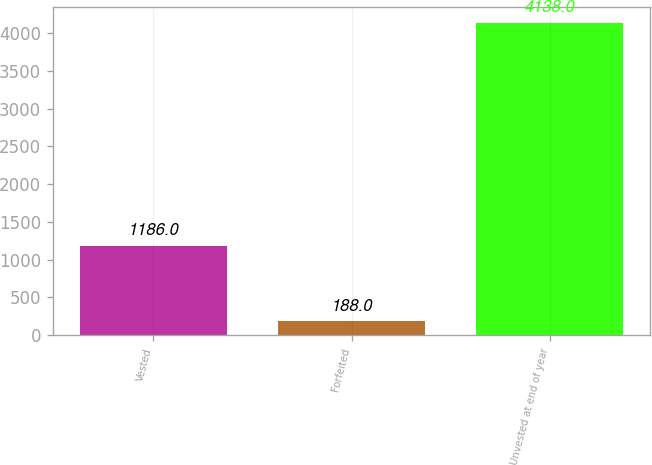Convert chart. <chart><loc_0><loc_0><loc_500><loc_500><bar_chart><fcel>Vested<fcel>Forfeited<fcel>Unvested at end of year<nl><fcel>1186<fcel>188<fcel>4138<nl></chart> 